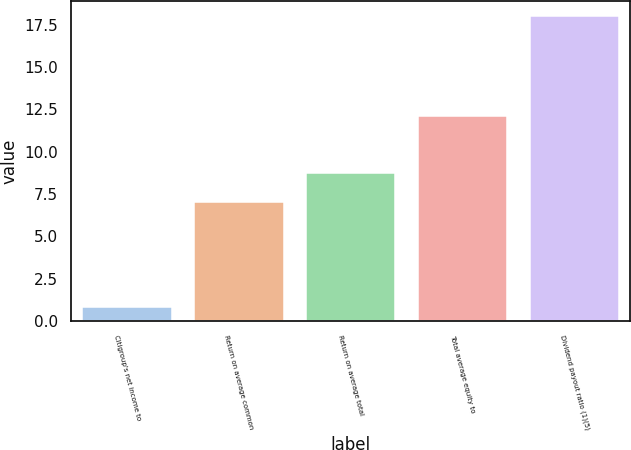Convert chart to OTSL. <chart><loc_0><loc_0><loc_500><loc_500><bar_chart><fcel>Citigroup's net income to<fcel>Return on average common<fcel>Return on average total<fcel>Total average equity to<fcel>Dividend payout ratio (1)(5)<nl><fcel>0.84<fcel>7<fcel>8.72<fcel>12.1<fcel>18<nl></chart> 